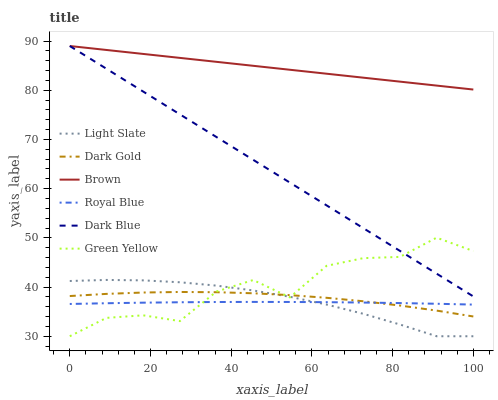Does Royal Blue have the minimum area under the curve?
Answer yes or no. Yes. Does Brown have the maximum area under the curve?
Answer yes or no. Yes. Does Light Slate have the minimum area under the curve?
Answer yes or no. No. Does Light Slate have the maximum area under the curve?
Answer yes or no. No. Is Dark Blue the smoothest?
Answer yes or no. Yes. Is Green Yellow the roughest?
Answer yes or no. Yes. Is Royal Blue the smoothest?
Answer yes or no. No. Is Royal Blue the roughest?
Answer yes or no. No. Does Royal Blue have the lowest value?
Answer yes or no. No. Does Dark Blue have the highest value?
Answer yes or no. Yes. Does Light Slate have the highest value?
Answer yes or no. No. Is Dark Gold less than Brown?
Answer yes or no. Yes. Is Dark Blue greater than Dark Gold?
Answer yes or no. Yes. Does Royal Blue intersect Green Yellow?
Answer yes or no. Yes. Is Royal Blue less than Green Yellow?
Answer yes or no. No. Is Royal Blue greater than Green Yellow?
Answer yes or no. No. Does Dark Gold intersect Brown?
Answer yes or no. No. 